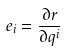Convert formula to latex. <formula><loc_0><loc_0><loc_500><loc_500>e _ { i } = \frac { \partial r } { \partial q ^ { i } }</formula> 